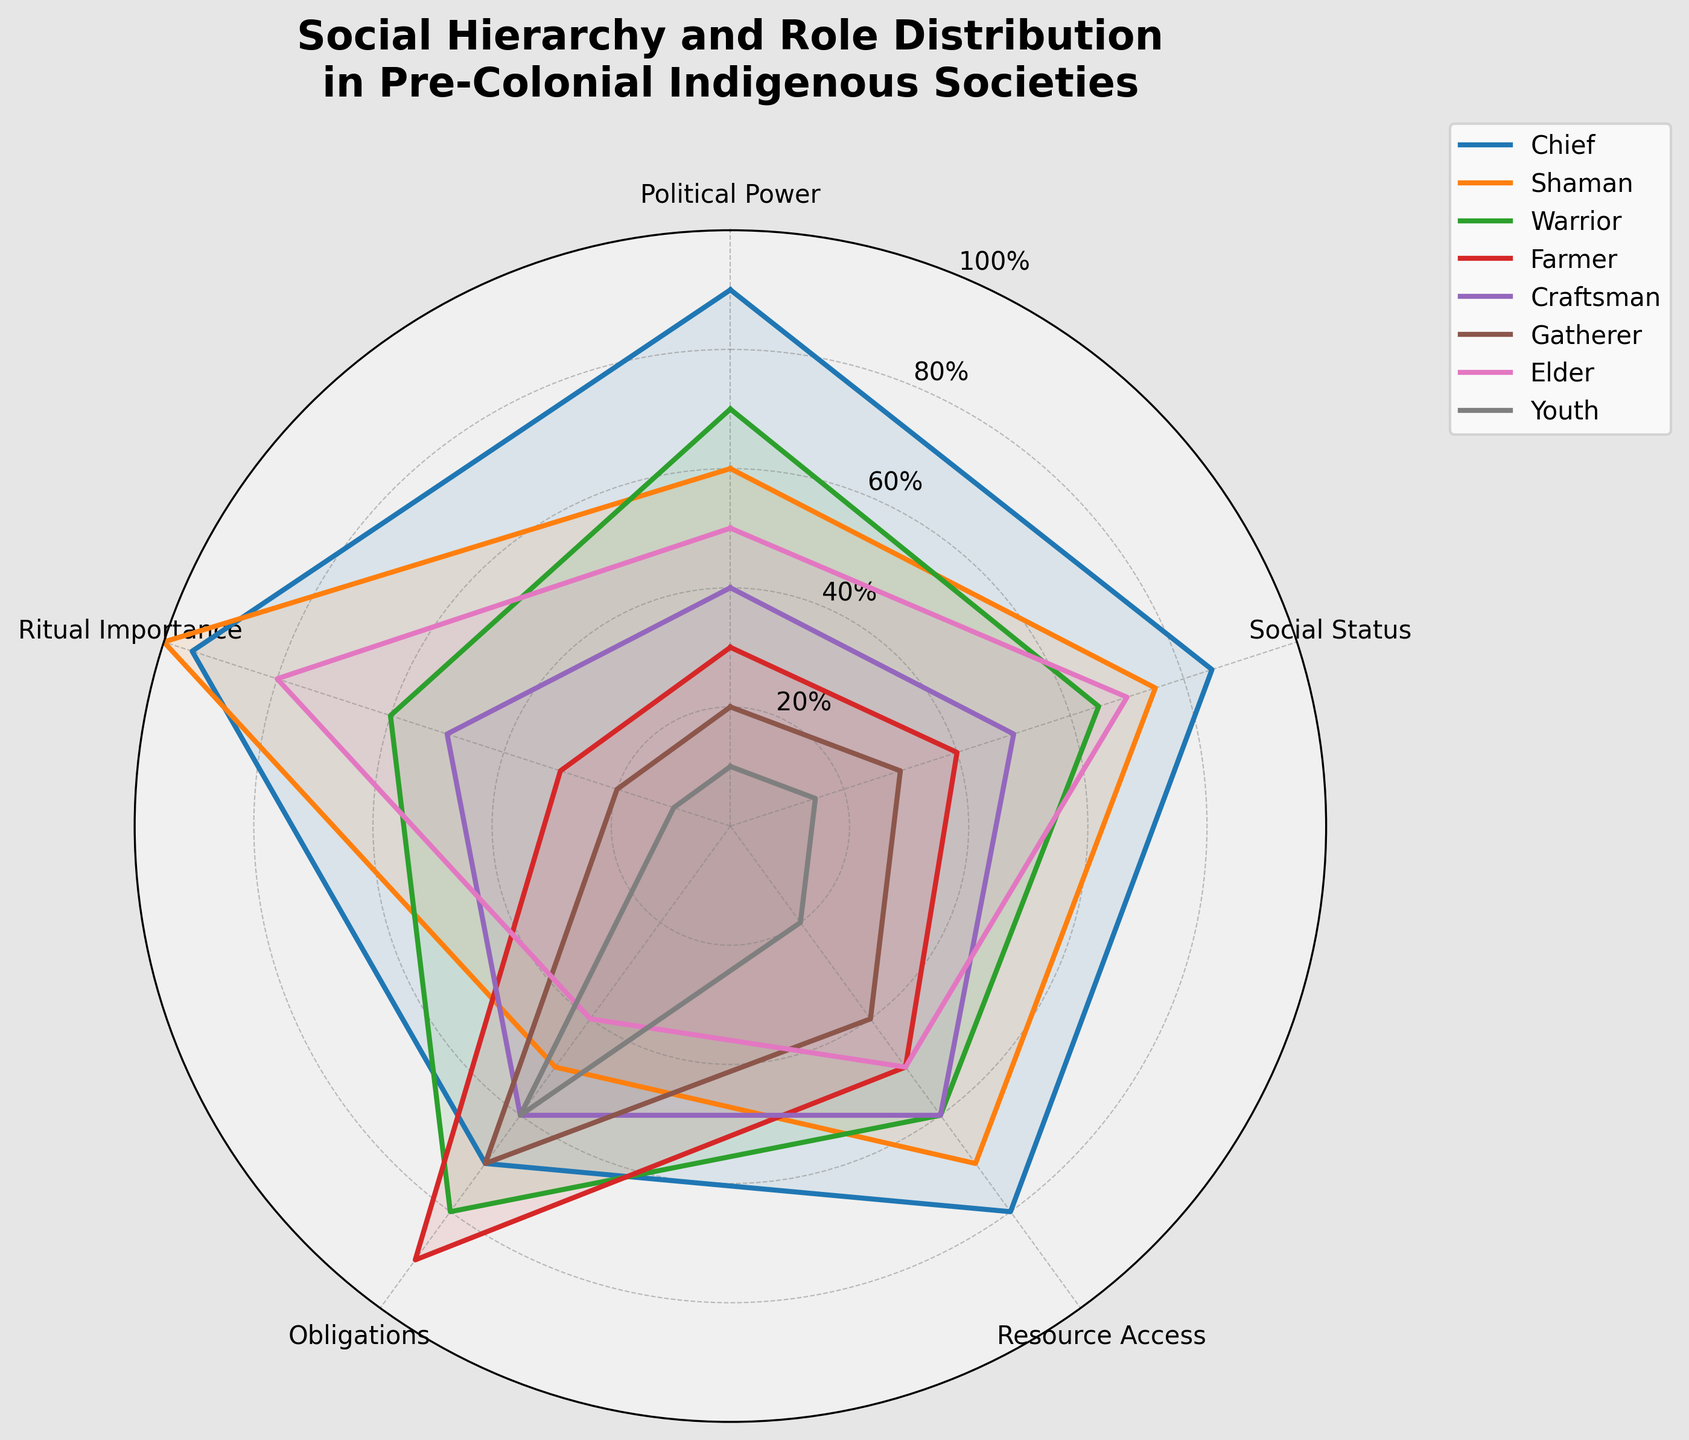What is the title of the radar chart? The title of the radar chart is displayed at the top of the figure. It reads, "Social Hierarchy and Role Distribution in Pre-Colonial Indigenous Societies".
Answer: Social Hierarchy and Role Distribution in Pre-Colonial Indigenous Societies Which role has the highest value in Ritual Importance? By looking at the values plotted on the Ritual Importance dimension of the radar chart, the Shaman role reaches 100, which is the highest.
Answer: Shaman What is the average Political Power of the Chief, Shaman, and Warrior? To find the average Political Power of the Chief, Shaman, and Warrior, sum their values (90 + 60 + 70) and then divide by 3. The calculation is (90 + 60 + 70) / 3 = 220 / 3 = 73.33.
Answer: 73.33 Which role has a higher Social Status, Elder or Craftsman? By comparing the points on the Social Status dimension, the Elder is at 70, while the Craftsman is at 50. Therefore, Elder has the higher Social Status.
Answer: Elder What is the smallest value for Resource Access and which role does it belong to? Viewing the Resource Access dimension, the smallest value is 20, which belongs to the Youth role.
Answer: Youth Which role has a lower level of Obligations, Shaman or Warrior? Comparing the Obligations values, the Shaman has a value of 50 while the Warrior has 80. Thus, the Shaman has a lower level of Obligations.
Answer: Shaman What are the main roles that form the innermost radius in the chart? Inspecting the innermost points on the chart, the roles closest to the center are Youth and Gatherer, with most of their values being the lowest among all roles.
Answer: Youth and Gatherer Considering the Farmer role, which aspect has the highest value and which has the lowest? Reviewing the points for the Farmer role, the highest value is for Obligations (90), and the lowest is for Ritual Importance (30).
Answer: Highest: Obligations; Lowest: Ritual Importance Compare the Resource Access of Chief and Gatherer. Which is higher, and by how much? The Chief has a Resource Access value of 80, while the Gatherer has 40. So, the Chief has 80 - 40 = 40 more Resource Access.
Answer: Chief by 40 Which categories do the Shaman and Warrior have as equal values? By examining the chart, both Shaman and Warrior have the same value for Political Power, which is 70 each.
Answer: Political Power 